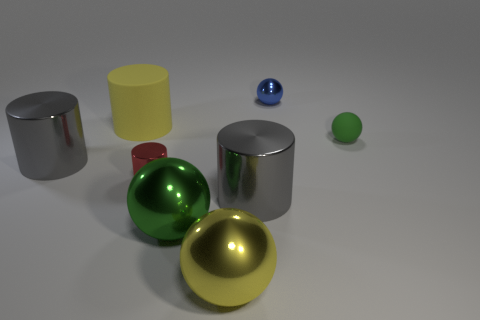There is another object that is the same color as the big rubber object; what shape is it?
Your answer should be compact. Sphere. Are there any things of the same color as the matte sphere?
Keep it short and to the point. Yes. There is a big yellow object that is to the left of the yellow shiny thing; what shape is it?
Keep it short and to the point. Cylinder. How many objects are both behind the large yellow sphere and in front of the tiny rubber sphere?
Give a very brief answer. 4. How many other objects are the same size as the green shiny object?
Your answer should be very brief. 4. There is a small thing behind the tiny green sphere; is its shape the same as the green object that is behind the tiny red thing?
Make the answer very short. Yes. How many objects are either small cylinders or balls that are behind the yellow metallic object?
Offer a terse response. 4. What is the tiny object that is both to the right of the tiny metal cylinder and in front of the small blue shiny sphere made of?
Keep it short and to the point. Rubber. There is a small sphere that is made of the same material as the big green ball; what color is it?
Give a very brief answer. Blue. How many objects are big yellow balls or big metal objects?
Provide a succinct answer. 4. 